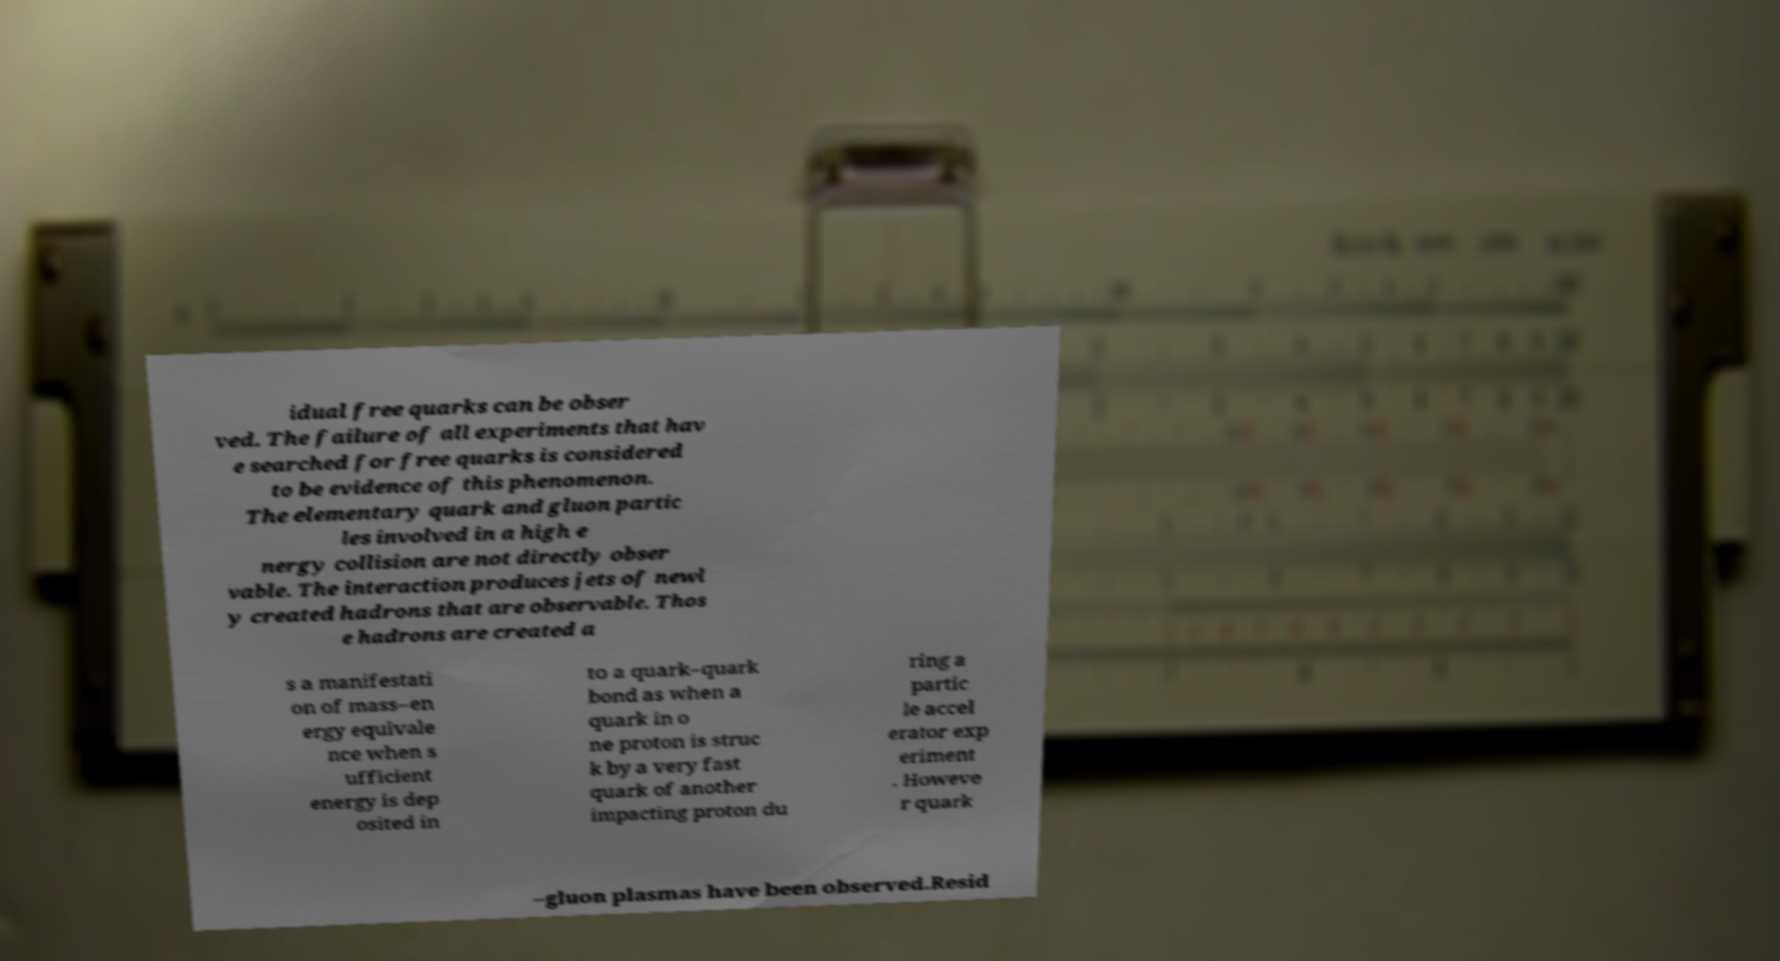There's text embedded in this image that I need extracted. Can you transcribe it verbatim? idual free quarks can be obser ved. The failure of all experiments that hav e searched for free quarks is considered to be evidence of this phenomenon. The elementary quark and gluon partic les involved in a high e nergy collision are not directly obser vable. The interaction produces jets of newl y created hadrons that are observable. Thos e hadrons are created a s a manifestati on of mass–en ergy equivale nce when s ufficient energy is dep osited in to a quark–quark bond as when a quark in o ne proton is struc k by a very fast quark of another impacting proton du ring a partic le accel erator exp eriment . Howeve r quark –gluon plasmas have been observed.Resid 